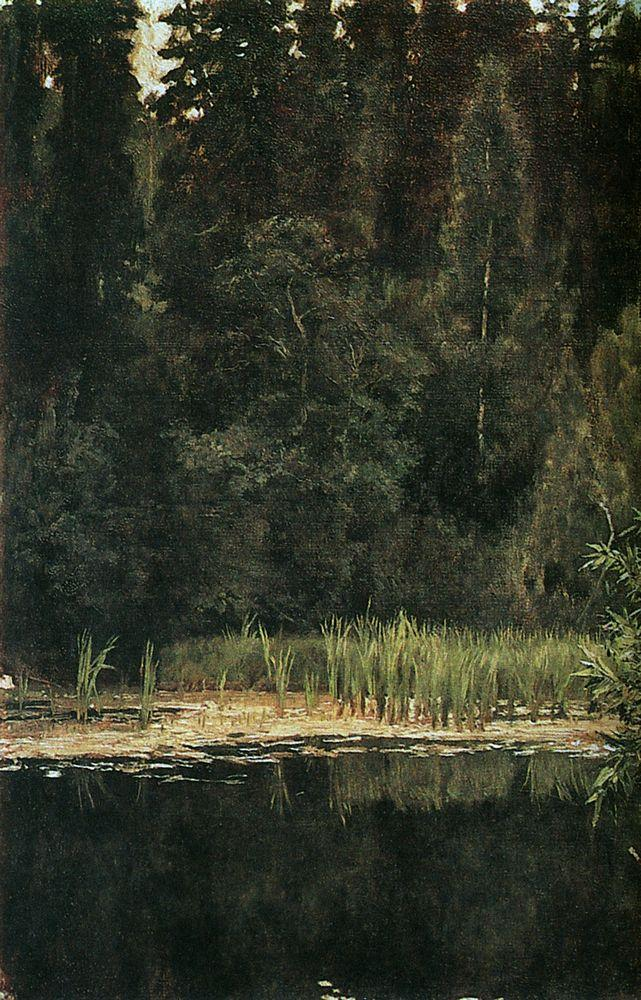Can you describe the main features of this image for me? This painting captures an enclosed forest glade with a dark canopy of trees that swallows most of the light, save for some that peeks through, dappling the forest floor. A still pond is present in a small clearing, acting as a mirror to the sparse sky visible above, with a fringe of reeds at its edge that introduces a contrast to the water's glassy surface. The use of light and shadow in the work suggests it could be an early evening scene, possibly in late summer when the foliage is lush but the light fades quickly. The painting invites contemplation, reminiscent of the 19th-century romanticism style where the subtleties of light and presence of water evokes a sense of introspection and emotional depth. The artist shows control and precision through the blending of colors and the soft transitions between different elements of the natural landscape. 